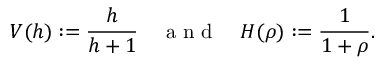<formula> <loc_0><loc_0><loc_500><loc_500>V ( h ) \colon = \frac { h } { h + 1 } \quad a n d \quad H ( \rho ) \colon = \frac { 1 } { 1 + \rho } .</formula> 